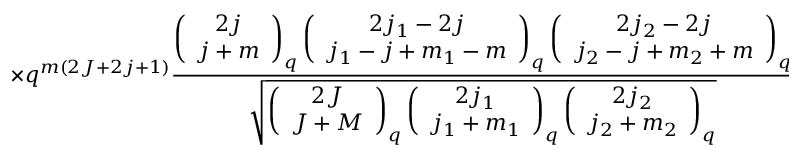<formula> <loc_0><loc_0><loc_500><loc_500>\times q ^ { m ( 2 J + 2 j + 1 ) } \frac { \left ( \begin{array} { c } { 2 j } \\ { j + m } \end{array} \right ) _ { q } \left ( \begin{array} { c } { { 2 j _ { 1 } - 2 j } } \\ { { j _ { 1 } - j + m _ { 1 } - m } } \end{array} \right ) _ { q } \left ( \begin{array} { c } { { 2 j _ { 2 } - 2 j } } \\ { { j _ { 2 } - j + m _ { 2 } + m } } \end{array} \right ) _ { q } } { \sqrt { \left ( \begin{array} { c } { 2 J } \\ { J + M } \end{array} \right ) _ { q } \left ( \begin{array} { c } { { 2 j _ { 1 } } } \\ { { j _ { 1 } + m _ { 1 } } } \end{array} \right ) _ { q } \left ( \begin{array} { c } { { 2 j _ { 2 } } } \\ { { j _ { 2 } + m _ { 2 } } } \end{array} \right ) _ { q } } }</formula> 